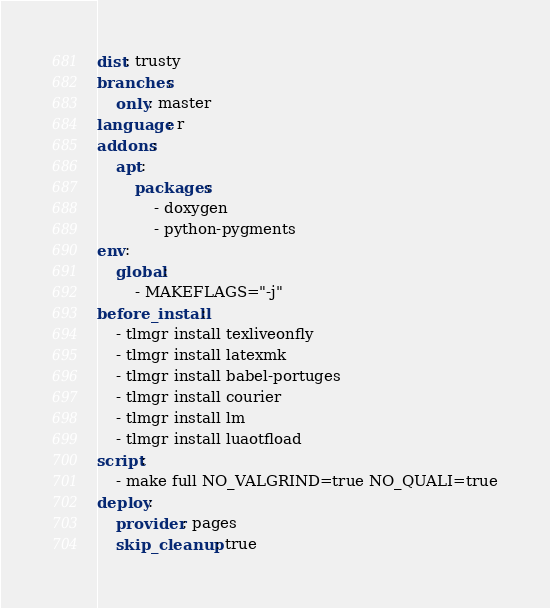<code> <loc_0><loc_0><loc_500><loc_500><_YAML_>dist: trusty
branches:
    only: master
language: r
addons:
    apt:
        packages:
            - doxygen
            - python-pygments
env:
    global:
        - MAKEFLAGS="-j"
before_install:
    - tlmgr install texliveonfly
    - tlmgr install latexmk
    - tlmgr install babel-portuges
    - tlmgr install courier
    - tlmgr install lm
    - tlmgr install luaotfload
script:
    - make full NO_VALGRIND=true NO_QUALI=true
deploy:
    provider: pages
    skip_cleanup: true</code> 